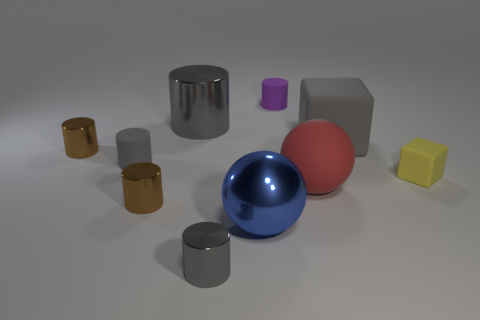Is there any other thing that has the same color as the large cylinder?
Make the answer very short. Yes. What color is the metallic thing that is the same shape as the big red rubber object?
Your answer should be compact. Blue. There is a matte thing that is behind the tiny gray rubber cylinder and in front of the tiny purple rubber object; how big is it?
Keep it short and to the point. Large. There is a gray metallic thing that is in front of the large matte sphere; is it the same shape as the gray matte object that is on the right side of the big metal cylinder?
Provide a short and direct response. No. What shape is the big metal object that is the same color as the large matte block?
Provide a succinct answer. Cylinder. What number of yellow blocks are made of the same material as the big cylinder?
Give a very brief answer. 0. There is a large object that is in front of the big gray metal cylinder and behind the yellow matte block; what shape is it?
Ensure brevity in your answer.  Cube. Is the material of the big gray thing that is behind the large matte block the same as the yellow cube?
Provide a short and direct response. No. Is there anything else that has the same material as the purple cylinder?
Make the answer very short. Yes. There is a cylinder that is the same size as the gray rubber block; what is its color?
Your answer should be compact. Gray. 